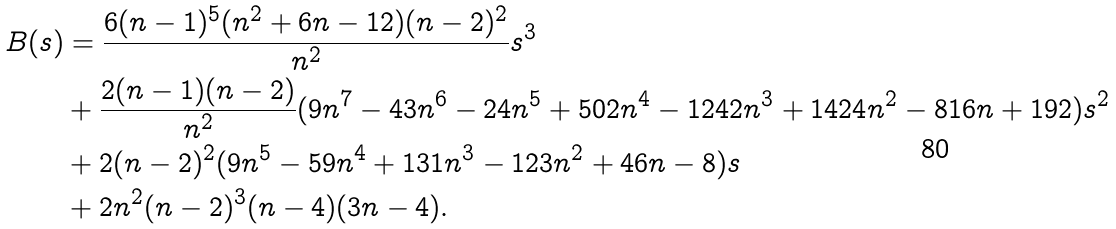<formula> <loc_0><loc_0><loc_500><loc_500>B ( s ) & = \frac { 6 ( n - 1 ) ^ { 5 } ( n ^ { 2 } + 6 n - 1 2 ) ( n - 2 ) ^ { 2 } } { n ^ { 2 } } s ^ { 3 } \\ & + \frac { 2 ( n - 1 ) ( n - 2 ) } { n ^ { 2 } } ( 9 n ^ { 7 } - 4 3 n ^ { 6 } - 2 4 n ^ { 5 } + 5 0 2 n ^ { 4 } - 1 2 4 2 n ^ { 3 } + 1 4 2 4 n ^ { 2 } - 8 1 6 n + 1 9 2 ) s ^ { 2 } \\ & + 2 ( n - 2 ) ^ { 2 } ( 9 n ^ { 5 } - 5 9 n ^ { 4 } + 1 3 1 n ^ { 3 } - 1 2 3 n ^ { 2 } + 4 6 n - 8 ) s \\ & + 2 n ^ { 2 } ( n - 2 ) ^ { 3 } ( n - 4 ) ( 3 n - 4 ) .</formula> 